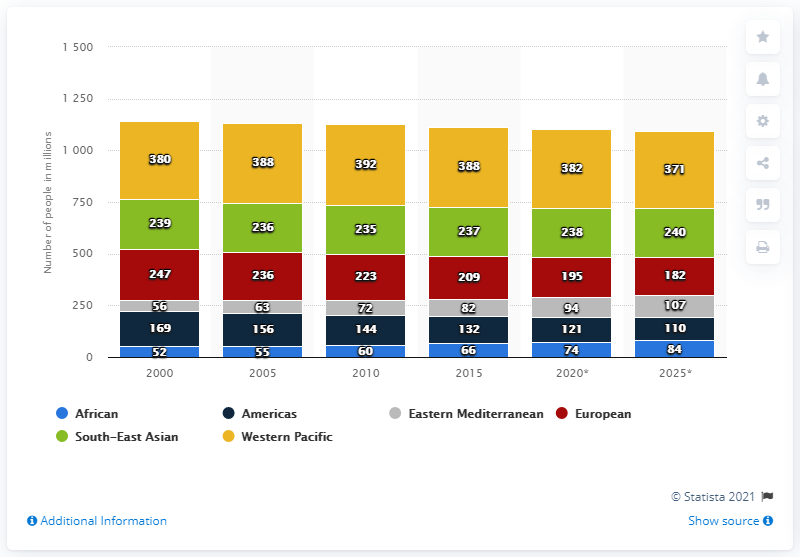List a handful of essential elements in this visual. In 2000, the population of tobacco smokers in Africa was estimated to be 52 million. According to estimates, the population of tobacco smokers in Africa is expected to reach approximately 84 million in 2025. 